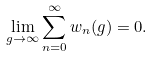Convert formula to latex. <formula><loc_0><loc_0><loc_500><loc_500>\lim _ { g \rightarrow \infty } \sum _ { n = 0 } ^ { \infty } w _ { n } ( g ) = 0 .</formula> 